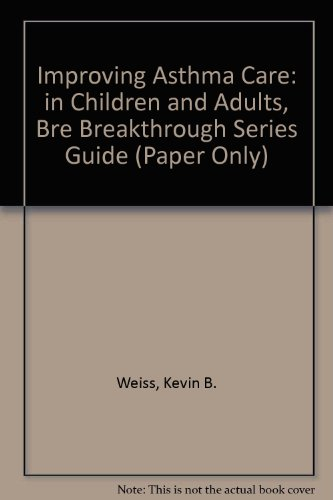What is the title of this book? The title of the book is 'Improving Asthma Care in Children and Adults', which is clearly displayed on the cover. 